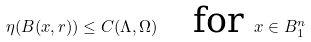<formula> <loc_0><loc_0><loc_500><loc_500>\eta ( B ( x , r ) ) \leq C ( \Lambda , \Omega ) \quad \text {for } x \in B _ { 1 } ^ { n }</formula> 